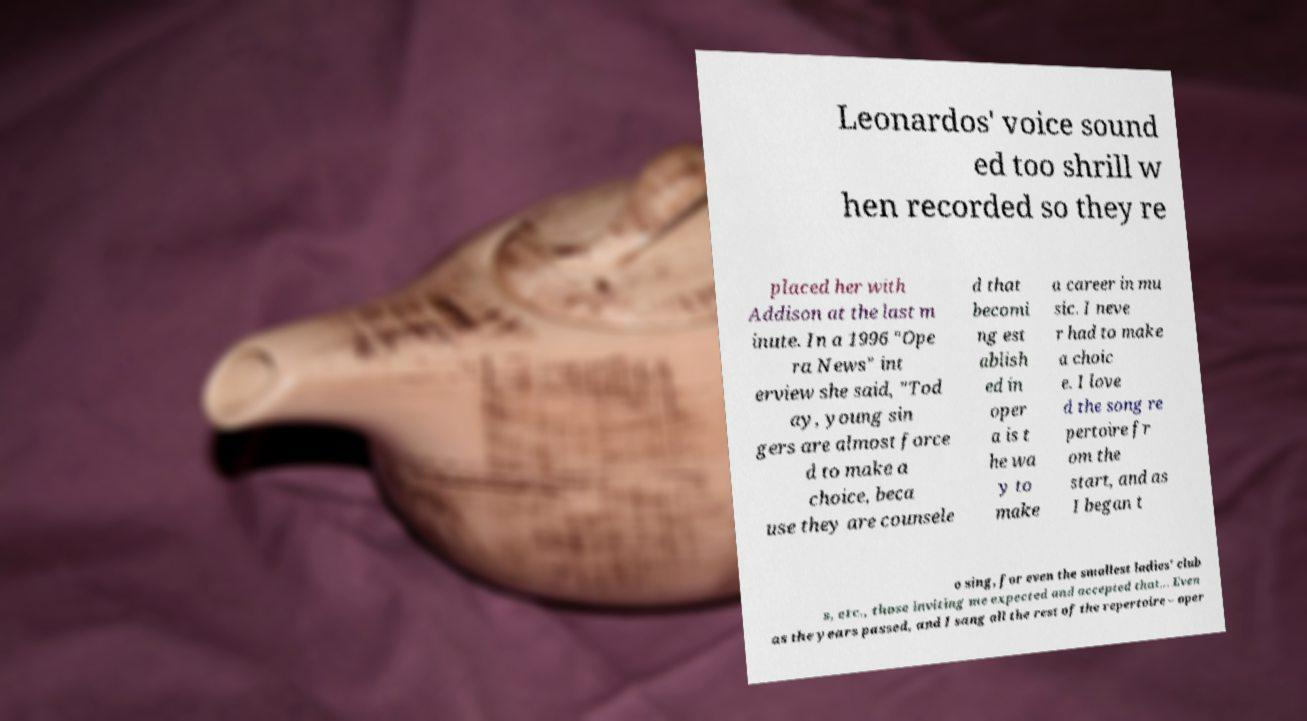There's text embedded in this image that I need extracted. Can you transcribe it verbatim? Leonardos' voice sound ed too shrill w hen recorded so they re placed her with Addison at the last m inute. In a 1996 "Ope ra News" int erview she said, "Tod ay, young sin gers are almost force d to make a choice, beca use they are counsele d that becomi ng est ablish ed in oper a is t he wa y to make a career in mu sic. I neve r had to make a choic e. I love d the song re pertoire fr om the start, and as I began t o sing, for even the smallest ladies' club s, etc., those inviting me expected and accepted that... Even as the years passed, and I sang all the rest of the repertoire – oper 